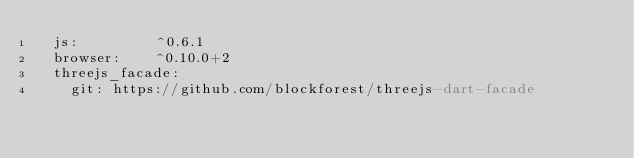<code> <loc_0><loc_0><loc_500><loc_500><_YAML_>  js:         ^0.6.1
  browser:    ^0.10.0+2
  threejs_facade:
    git: https://github.com/blockforest/threejs-dart-facade
</code> 